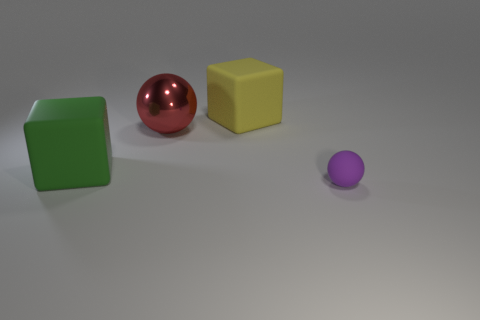How many objects are either blue spheres or things in front of the red metallic thing?
Your answer should be very brief. 2. There is a thing that is in front of the big shiny ball and on the left side of the big yellow block; what is its shape?
Make the answer very short. Cube. What is the material of the sphere that is behind the big block in front of the yellow rubber block?
Provide a short and direct response. Metal. Does the object behind the shiny sphere have the same material as the purple sphere?
Provide a short and direct response. Yes. What size is the rubber object that is left of the yellow rubber thing?
Make the answer very short. Large. There is a big object in front of the big metallic ball; are there any red shiny balls that are in front of it?
Provide a succinct answer. No. What color is the shiny thing?
Offer a very short reply. Red. Are there any other things of the same color as the tiny sphere?
Offer a terse response. No. What color is the big object that is both right of the green rubber thing and in front of the large yellow object?
Give a very brief answer. Red. Is the size of the ball that is left of the purple object the same as the small purple ball?
Ensure brevity in your answer.  No. 